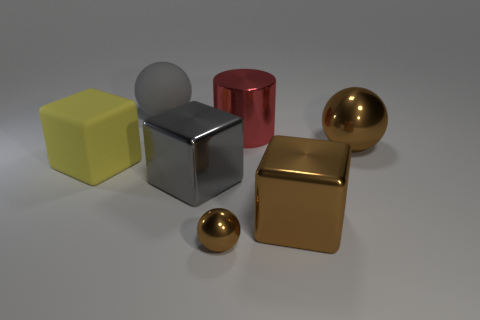Subtract all red cubes. Subtract all green cylinders. How many cubes are left? 3 Add 2 big gray things. How many objects exist? 9 Subtract all cylinders. How many objects are left? 6 Subtract 0 cyan spheres. How many objects are left? 7 Subtract all large purple metal blocks. Subtract all red shiny cylinders. How many objects are left? 6 Add 7 metal cylinders. How many metal cylinders are left? 8 Add 1 large balls. How many large balls exist? 3 